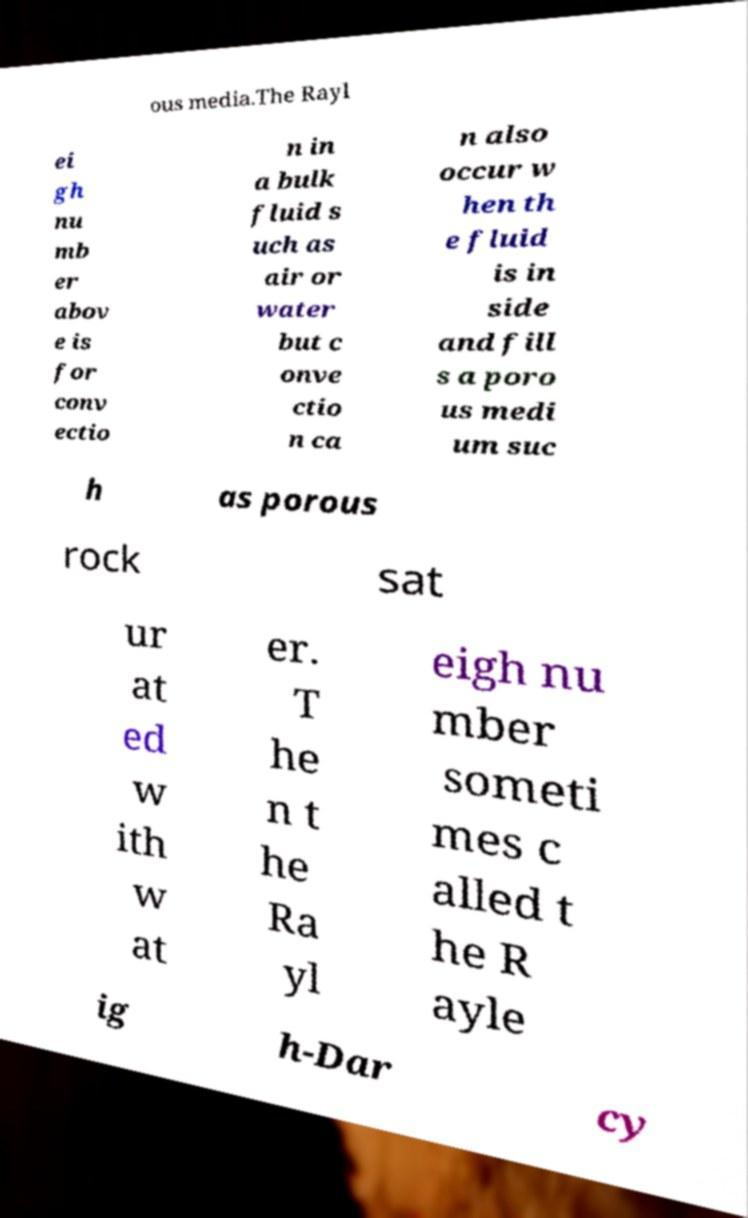Please identify and transcribe the text found in this image. ous media.The Rayl ei gh nu mb er abov e is for conv ectio n in a bulk fluid s uch as air or water but c onve ctio n ca n also occur w hen th e fluid is in side and fill s a poro us medi um suc h as porous rock sat ur at ed w ith w at er. T he n t he Ra yl eigh nu mber someti mes c alled t he R ayle ig h-Dar cy 